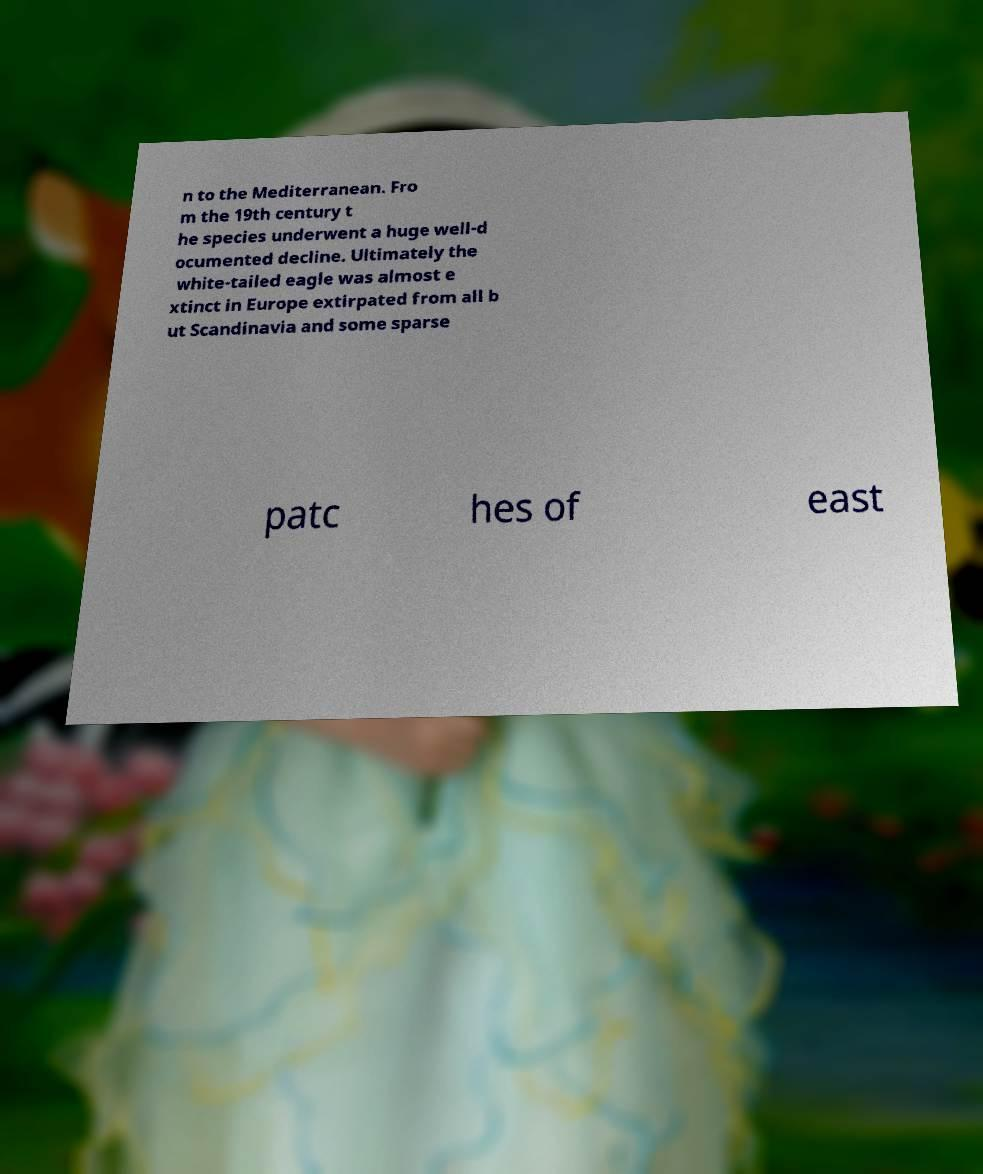For documentation purposes, I need the text within this image transcribed. Could you provide that? n to the Mediterranean. Fro m the 19th century t he species underwent a huge well-d ocumented decline. Ultimately the white-tailed eagle was almost e xtinct in Europe extirpated from all b ut Scandinavia and some sparse patc hes of east 